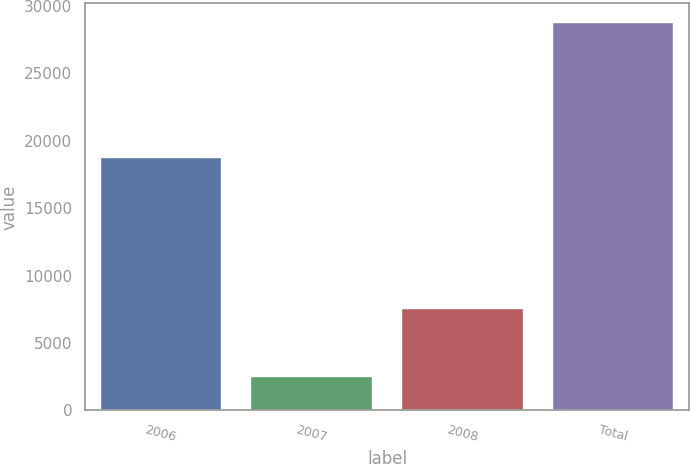Convert chart to OTSL. <chart><loc_0><loc_0><loc_500><loc_500><bar_chart><fcel>2006<fcel>2007<fcel>2008<fcel>Total<nl><fcel>18759<fcel>2500<fcel>7500<fcel>28759<nl></chart> 